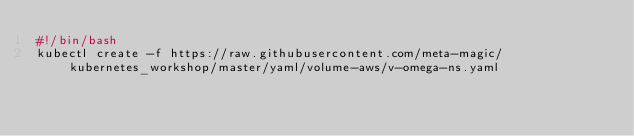Convert code to text. <code><loc_0><loc_0><loc_500><loc_500><_Bash_>#!/bin/bash
kubectl create -f https://raw.githubusercontent.com/meta-magic/kubernetes_workshop/master/yaml/volume-aws/v-omega-ns.yaml</code> 